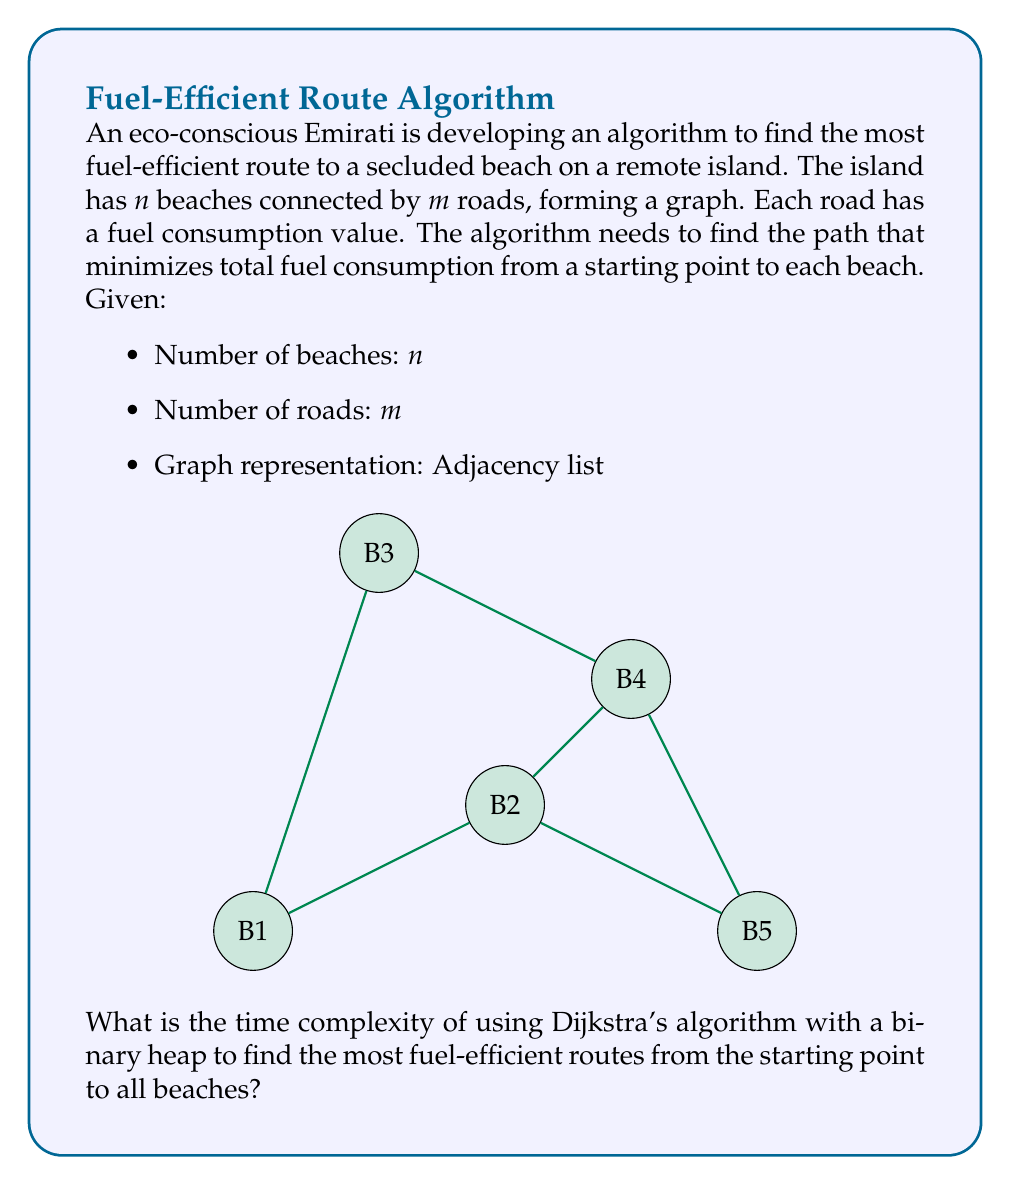Solve this math problem. To solve this problem, we'll analyze Dijkstra's algorithm with a binary heap implementation:

1) Initialization:
   - Create a min-heap with $n$ elements: $O(n)$
   - Initialize distances: $O(n)$

2) Main loop:
   - Extract-min operation: $O(\log n)$
   - This is done $n$ times (once for each beach): $O(n \log n)$

3) For each extracted node:
   - Update distances to adjacent nodes
   - Each update involves a decrease-key operation: $O(\log n)$
   - In total, we perform at most $m$ decrease-key operations

4) Total time for decrease-key operations:
   $O(m \log n)$

5) Combining all steps:
   $O(n) + O(n \log n) + O(m \log n)$

6) Simplify:
   $O((n + m) \log n)$

In a connected graph, $m \geq n - 1$, so we can further simplify to:
$O(m \log n)$

This time complexity allows the eco-conscious Emirati to efficiently find the most fuel-efficient routes to all secluded beaches, minimizing environmental impact.
Answer: $O(m \log n)$ 